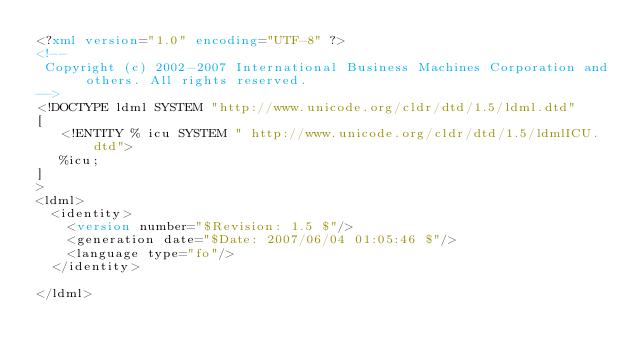<code> <loc_0><loc_0><loc_500><loc_500><_XML_><?xml version="1.0" encoding="UTF-8" ?>
<!--
 Copyright (c) 2002-2007 International Business Machines Corporation and others. All rights reserved.
-->
<!DOCTYPE ldml SYSTEM "http://www.unicode.org/cldr/dtd/1.5/ldml.dtd"
[
   <!ENTITY % icu SYSTEM " http://www.unicode.org/cldr/dtd/1.5/ldmlICU.dtd">
   %icu;
]
>
<ldml>
	<identity>
		<version number="$Revision: 1.5 $"/>
		<generation date="$Date: 2007/06/04 01:05:46 $"/>
		<language type="fo"/> 
	</identity>
	
</ldml>

</code> 